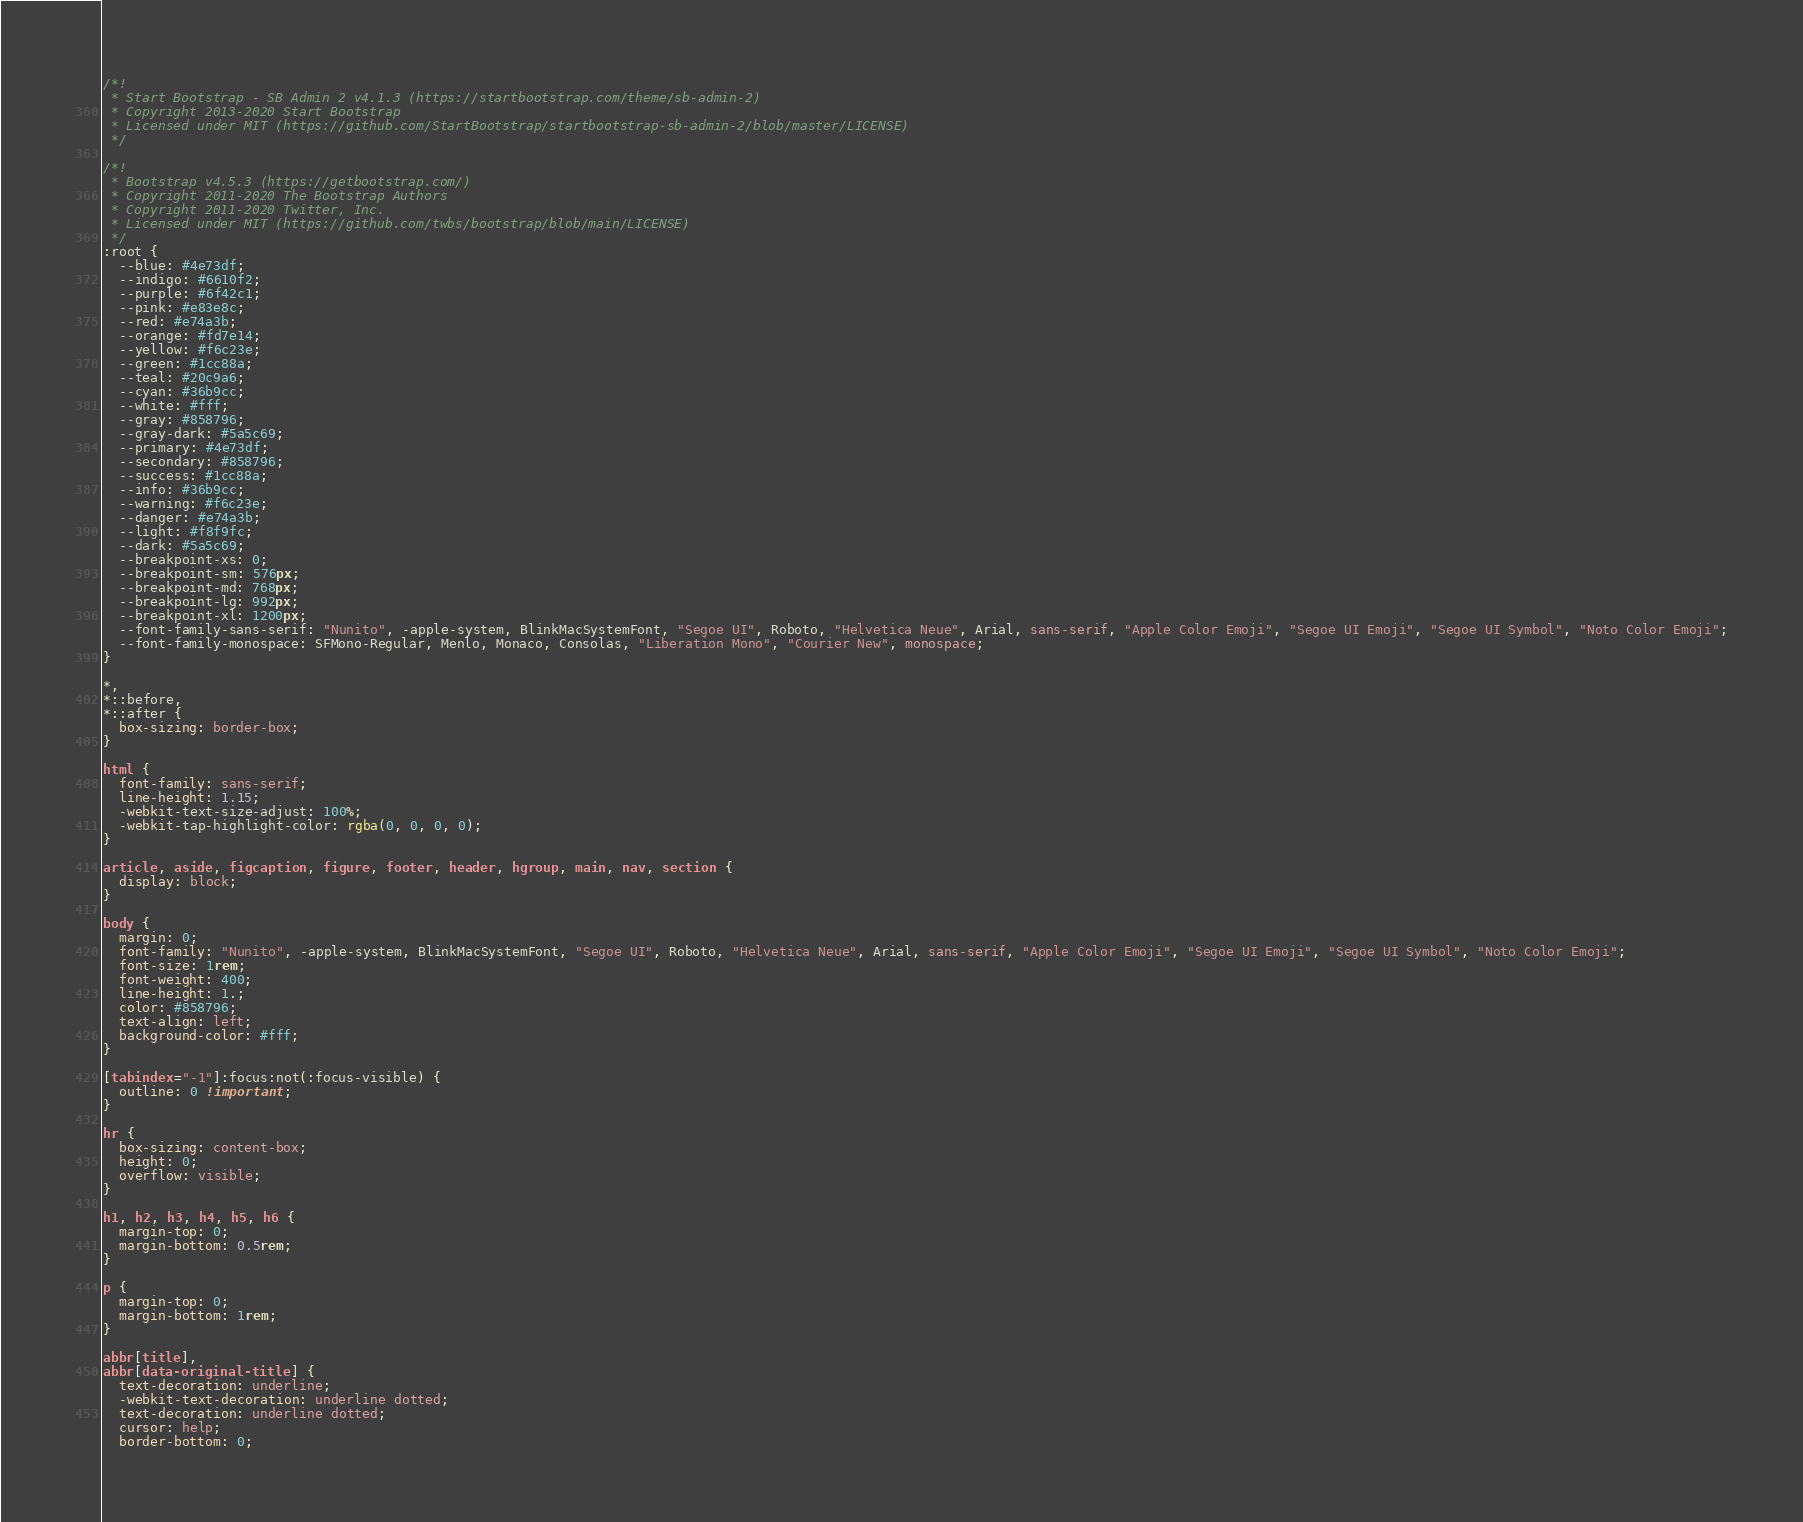Convert code to text. <code><loc_0><loc_0><loc_500><loc_500><_CSS_>/*!
 * Start Bootstrap - SB Admin 2 v4.1.3 (https://startbootstrap.com/theme/sb-admin-2)
 * Copyright 2013-2020 Start Bootstrap
 * Licensed under MIT (https://github.com/StartBootstrap/startbootstrap-sb-admin-2/blob/master/LICENSE)
 */

/*!
 * Bootstrap v4.5.3 (https://getbootstrap.com/)
 * Copyright 2011-2020 The Bootstrap Authors
 * Copyright 2011-2020 Twitter, Inc.
 * Licensed under MIT (https://github.com/twbs/bootstrap/blob/main/LICENSE)
 */
:root {
  --blue: #4e73df;
  --indigo: #6610f2;
  --purple: #6f42c1;
  --pink: #e83e8c;
  --red: #e74a3b;
  --orange: #fd7e14;
  --yellow: #f6c23e;
  --green: #1cc88a;
  --teal: #20c9a6;
  --cyan: #36b9cc;
  --white: #fff;
  --gray: #858796;
  --gray-dark: #5a5c69;
  --primary: #4e73df;
  --secondary: #858796;
  --success: #1cc88a;
  --info: #36b9cc;
  --warning: #f6c23e;
  --danger: #e74a3b;
  --light: #f8f9fc;
  --dark: #5a5c69;
  --breakpoint-xs: 0;
  --breakpoint-sm: 576px;
  --breakpoint-md: 768px;
  --breakpoint-lg: 992px;
  --breakpoint-xl: 1200px;
  --font-family-sans-serif: "Nunito", -apple-system, BlinkMacSystemFont, "Segoe UI", Roboto, "Helvetica Neue", Arial, sans-serif, "Apple Color Emoji", "Segoe UI Emoji", "Segoe UI Symbol", "Noto Color Emoji";
  --font-family-monospace: SFMono-Regular, Menlo, Monaco, Consolas, "Liberation Mono", "Courier New", monospace;
}

*,
*::before,
*::after {
  box-sizing: border-box;
}

html {
  font-family: sans-serif;
  line-height: 1.15;
  -webkit-text-size-adjust: 100%;
  -webkit-tap-highlight-color: rgba(0, 0, 0, 0);
}

article, aside, figcaption, figure, footer, header, hgroup, main, nav, section {
  display: block;
}

body {
  margin: 0;
  font-family: "Nunito", -apple-system, BlinkMacSystemFont, "Segoe UI", Roboto, "Helvetica Neue", Arial, sans-serif, "Apple Color Emoji", "Segoe UI Emoji", "Segoe UI Symbol", "Noto Color Emoji";
  font-size: 1rem;
  font-weight: 400;
  line-height: 1.;
  color: #858796;
  text-align: left;
  background-color: #fff;
}

[tabindex="-1"]:focus:not(:focus-visible) {
  outline: 0 !important;
}

hr {
  box-sizing: content-box;
  height: 0;
  overflow: visible;
}

h1, h2, h3, h4, h5, h6 {
  margin-top: 0;
  margin-bottom: 0.5rem;
}

p {
  margin-top: 0;
  margin-bottom: 1rem;
}

abbr[title],
abbr[data-original-title] {
  text-decoration: underline;
  -webkit-text-decoration: underline dotted;
  text-decoration: underline dotted;
  cursor: help;
  border-bottom: 0;</code> 